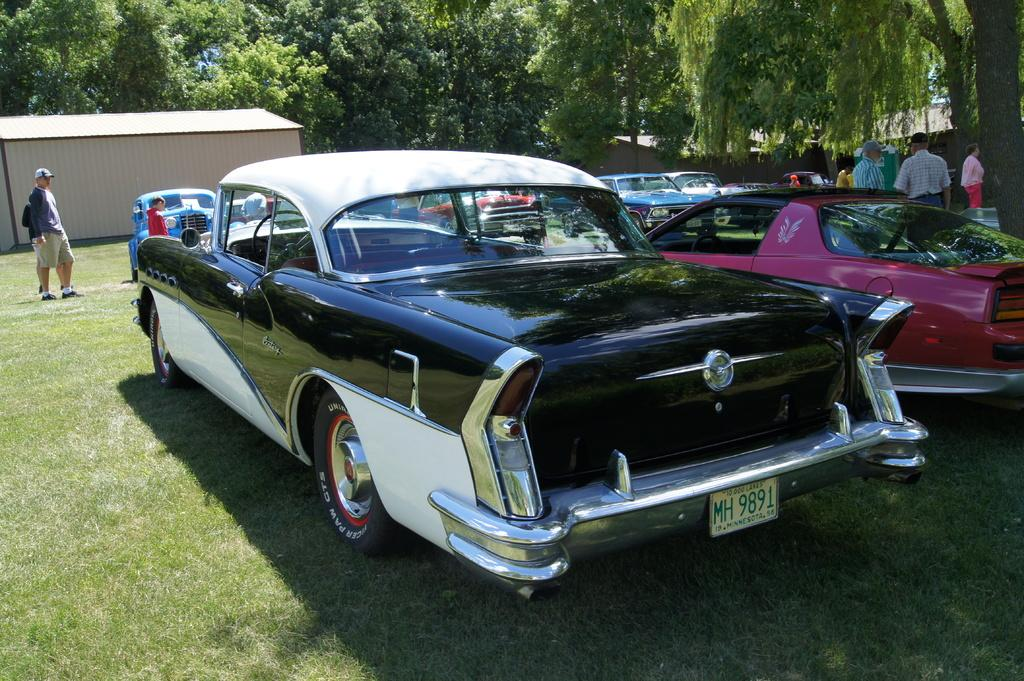What is located in the center of the image? There are cars on the grass in the center of the image. What can be seen in the background of the image? There are trees in the background of the image. Can you describe the person in the image? There is a person standing in the image. What type of structure is present in the image? There is a shed in the image. What type of pet can be seen walking around the cars in the image? There is no pet visible in the image; it only shows cars on the grass, trees in the background, a person standing, and a shed. 